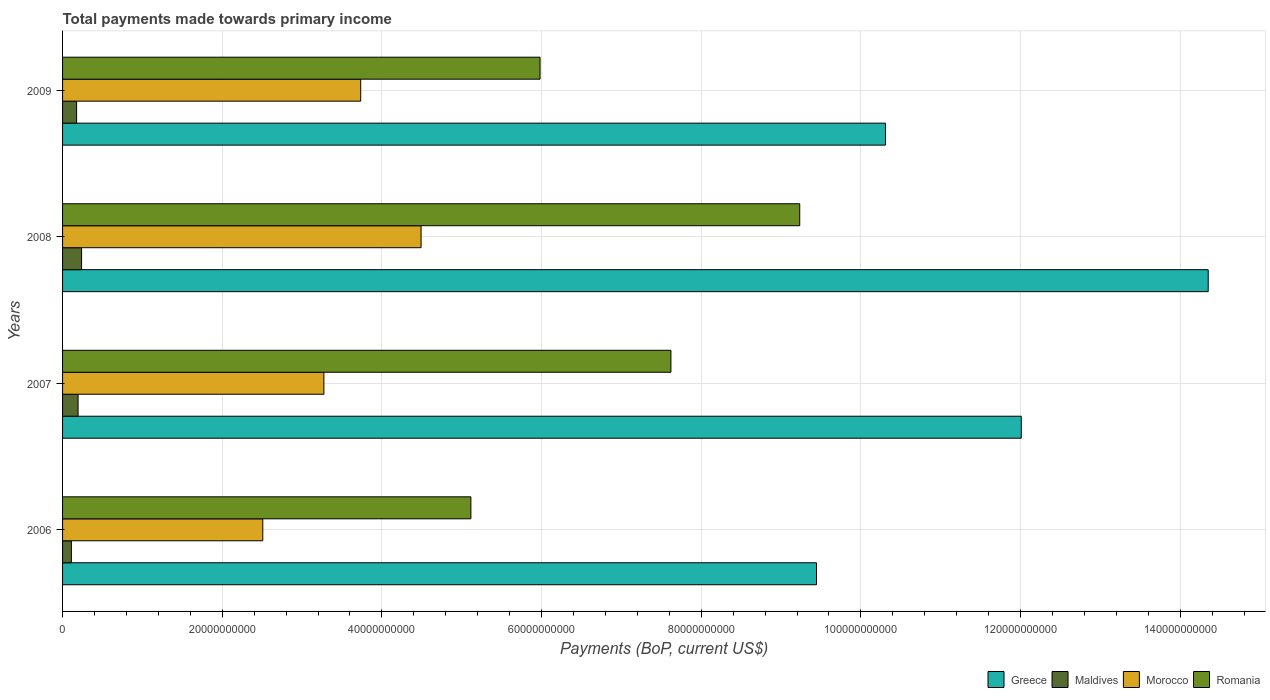How many different coloured bars are there?
Keep it short and to the point. 4. Are the number of bars per tick equal to the number of legend labels?
Your answer should be very brief. Yes. How many bars are there on the 2nd tick from the bottom?
Your answer should be very brief. 4. What is the label of the 2nd group of bars from the top?
Keep it short and to the point. 2008. What is the total payments made towards primary income in Romania in 2009?
Offer a terse response. 5.98e+1. Across all years, what is the maximum total payments made towards primary income in Greece?
Provide a short and direct response. 1.44e+11. Across all years, what is the minimum total payments made towards primary income in Maldives?
Ensure brevity in your answer.  1.10e+09. What is the total total payments made towards primary income in Maldives in the graph?
Your response must be concise. 7.18e+09. What is the difference between the total payments made towards primary income in Maldives in 2006 and that in 2008?
Your answer should be very brief. -1.28e+09. What is the difference between the total payments made towards primary income in Romania in 2006 and the total payments made towards primary income in Morocco in 2009?
Make the answer very short. 1.38e+1. What is the average total payments made towards primary income in Romania per year?
Offer a very short reply. 6.99e+1. In the year 2006, what is the difference between the total payments made towards primary income in Romania and total payments made towards primary income in Maldives?
Offer a very short reply. 5.00e+1. In how many years, is the total payments made towards primary income in Morocco greater than 40000000000 US$?
Make the answer very short. 1. What is the ratio of the total payments made towards primary income in Greece in 2007 to that in 2009?
Your answer should be very brief. 1.17. Is the total payments made towards primary income in Romania in 2008 less than that in 2009?
Offer a terse response. No. What is the difference between the highest and the second highest total payments made towards primary income in Greece?
Provide a short and direct response. 2.34e+1. What is the difference between the highest and the lowest total payments made towards primary income in Greece?
Offer a terse response. 4.91e+1. What does the 1st bar from the top in 2006 represents?
Ensure brevity in your answer.  Romania. What does the 3rd bar from the bottom in 2006 represents?
Your answer should be compact. Morocco. How many bars are there?
Provide a short and direct response. 16. Are all the bars in the graph horizontal?
Provide a short and direct response. Yes. How many years are there in the graph?
Ensure brevity in your answer.  4. What is the difference between two consecutive major ticks on the X-axis?
Ensure brevity in your answer.  2.00e+1. Are the values on the major ticks of X-axis written in scientific E-notation?
Give a very brief answer. No. Does the graph contain any zero values?
Provide a short and direct response. No. Does the graph contain grids?
Your answer should be very brief. Yes. What is the title of the graph?
Your response must be concise. Total payments made towards primary income. Does "Kuwait" appear as one of the legend labels in the graph?
Offer a very short reply. No. What is the label or title of the X-axis?
Offer a terse response. Payments (BoP, current US$). What is the Payments (BoP, current US$) of Greece in 2006?
Provide a short and direct response. 9.44e+1. What is the Payments (BoP, current US$) in Maldives in 2006?
Your response must be concise. 1.10e+09. What is the Payments (BoP, current US$) of Morocco in 2006?
Offer a terse response. 2.51e+1. What is the Payments (BoP, current US$) of Romania in 2006?
Your answer should be compact. 5.11e+1. What is the Payments (BoP, current US$) in Greece in 2007?
Make the answer very short. 1.20e+11. What is the Payments (BoP, current US$) of Maldives in 2007?
Make the answer very short. 1.94e+09. What is the Payments (BoP, current US$) of Morocco in 2007?
Your response must be concise. 3.27e+1. What is the Payments (BoP, current US$) of Romania in 2007?
Offer a very short reply. 7.62e+1. What is the Payments (BoP, current US$) in Greece in 2008?
Provide a succinct answer. 1.44e+11. What is the Payments (BoP, current US$) of Maldives in 2008?
Offer a terse response. 2.38e+09. What is the Payments (BoP, current US$) of Morocco in 2008?
Give a very brief answer. 4.49e+1. What is the Payments (BoP, current US$) of Romania in 2008?
Offer a terse response. 9.23e+1. What is the Payments (BoP, current US$) of Greece in 2009?
Provide a succinct answer. 1.03e+11. What is the Payments (BoP, current US$) of Maldives in 2009?
Ensure brevity in your answer.  1.76e+09. What is the Payments (BoP, current US$) of Morocco in 2009?
Provide a succinct answer. 3.73e+1. What is the Payments (BoP, current US$) in Romania in 2009?
Provide a succinct answer. 5.98e+1. Across all years, what is the maximum Payments (BoP, current US$) of Greece?
Offer a very short reply. 1.44e+11. Across all years, what is the maximum Payments (BoP, current US$) in Maldives?
Make the answer very short. 2.38e+09. Across all years, what is the maximum Payments (BoP, current US$) in Morocco?
Offer a terse response. 4.49e+1. Across all years, what is the maximum Payments (BoP, current US$) of Romania?
Keep it short and to the point. 9.23e+1. Across all years, what is the minimum Payments (BoP, current US$) in Greece?
Ensure brevity in your answer.  9.44e+1. Across all years, what is the minimum Payments (BoP, current US$) of Maldives?
Offer a very short reply. 1.10e+09. Across all years, what is the minimum Payments (BoP, current US$) of Morocco?
Offer a terse response. 2.51e+1. Across all years, what is the minimum Payments (BoP, current US$) in Romania?
Your response must be concise. 5.11e+1. What is the total Payments (BoP, current US$) in Greece in the graph?
Ensure brevity in your answer.  4.61e+11. What is the total Payments (BoP, current US$) of Maldives in the graph?
Keep it short and to the point. 7.18e+09. What is the total Payments (BoP, current US$) in Morocco in the graph?
Offer a very short reply. 1.40e+11. What is the total Payments (BoP, current US$) in Romania in the graph?
Your answer should be very brief. 2.80e+11. What is the difference between the Payments (BoP, current US$) of Greece in 2006 and that in 2007?
Keep it short and to the point. -2.56e+1. What is the difference between the Payments (BoP, current US$) in Maldives in 2006 and that in 2007?
Your answer should be very brief. -8.40e+08. What is the difference between the Payments (BoP, current US$) of Morocco in 2006 and that in 2007?
Your answer should be compact. -7.65e+09. What is the difference between the Payments (BoP, current US$) in Romania in 2006 and that in 2007?
Provide a succinct answer. -2.51e+1. What is the difference between the Payments (BoP, current US$) of Greece in 2006 and that in 2008?
Your response must be concise. -4.91e+1. What is the difference between the Payments (BoP, current US$) of Maldives in 2006 and that in 2008?
Offer a very short reply. -1.28e+09. What is the difference between the Payments (BoP, current US$) of Morocco in 2006 and that in 2008?
Your answer should be very brief. -1.98e+1. What is the difference between the Payments (BoP, current US$) in Romania in 2006 and that in 2008?
Ensure brevity in your answer.  -4.12e+1. What is the difference between the Payments (BoP, current US$) in Greece in 2006 and that in 2009?
Make the answer very short. -8.64e+09. What is the difference between the Payments (BoP, current US$) in Maldives in 2006 and that in 2009?
Ensure brevity in your answer.  -6.55e+08. What is the difference between the Payments (BoP, current US$) in Morocco in 2006 and that in 2009?
Your answer should be compact. -1.23e+1. What is the difference between the Payments (BoP, current US$) of Romania in 2006 and that in 2009?
Keep it short and to the point. -8.66e+09. What is the difference between the Payments (BoP, current US$) of Greece in 2007 and that in 2008?
Offer a terse response. -2.34e+1. What is the difference between the Payments (BoP, current US$) in Maldives in 2007 and that in 2008?
Provide a short and direct response. -4.38e+08. What is the difference between the Payments (BoP, current US$) in Morocco in 2007 and that in 2008?
Your response must be concise. -1.22e+1. What is the difference between the Payments (BoP, current US$) of Romania in 2007 and that in 2008?
Offer a terse response. -1.61e+1. What is the difference between the Payments (BoP, current US$) in Greece in 2007 and that in 2009?
Offer a very short reply. 1.70e+1. What is the difference between the Payments (BoP, current US$) of Maldives in 2007 and that in 2009?
Your response must be concise. 1.85e+08. What is the difference between the Payments (BoP, current US$) of Morocco in 2007 and that in 2009?
Your answer should be compact. -4.61e+09. What is the difference between the Payments (BoP, current US$) in Romania in 2007 and that in 2009?
Give a very brief answer. 1.64e+1. What is the difference between the Payments (BoP, current US$) in Greece in 2008 and that in 2009?
Give a very brief answer. 4.04e+1. What is the difference between the Payments (BoP, current US$) of Maldives in 2008 and that in 2009?
Give a very brief answer. 6.23e+08. What is the difference between the Payments (BoP, current US$) in Morocco in 2008 and that in 2009?
Provide a succinct answer. 7.56e+09. What is the difference between the Payments (BoP, current US$) of Romania in 2008 and that in 2009?
Your answer should be compact. 3.25e+1. What is the difference between the Payments (BoP, current US$) in Greece in 2006 and the Payments (BoP, current US$) in Maldives in 2007?
Your answer should be compact. 9.25e+1. What is the difference between the Payments (BoP, current US$) in Greece in 2006 and the Payments (BoP, current US$) in Morocco in 2007?
Ensure brevity in your answer.  6.17e+1. What is the difference between the Payments (BoP, current US$) in Greece in 2006 and the Payments (BoP, current US$) in Romania in 2007?
Give a very brief answer. 1.82e+1. What is the difference between the Payments (BoP, current US$) of Maldives in 2006 and the Payments (BoP, current US$) of Morocco in 2007?
Ensure brevity in your answer.  -3.16e+1. What is the difference between the Payments (BoP, current US$) in Maldives in 2006 and the Payments (BoP, current US$) in Romania in 2007?
Offer a terse response. -7.51e+1. What is the difference between the Payments (BoP, current US$) of Morocco in 2006 and the Payments (BoP, current US$) of Romania in 2007?
Offer a very short reply. -5.11e+1. What is the difference between the Payments (BoP, current US$) in Greece in 2006 and the Payments (BoP, current US$) in Maldives in 2008?
Provide a short and direct response. 9.21e+1. What is the difference between the Payments (BoP, current US$) in Greece in 2006 and the Payments (BoP, current US$) in Morocco in 2008?
Give a very brief answer. 4.95e+1. What is the difference between the Payments (BoP, current US$) in Greece in 2006 and the Payments (BoP, current US$) in Romania in 2008?
Make the answer very short. 2.10e+09. What is the difference between the Payments (BoP, current US$) in Maldives in 2006 and the Payments (BoP, current US$) in Morocco in 2008?
Offer a very short reply. -4.38e+1. What is the difference between the Payments (BoP, current US$) of Maldives in 2006 and the Payments (BoP, current US$) of Romania in 2008?
Your answer should be very brief. -9.12e+1. What is the difference between the Payments (BoP, current US$) in Morocco in 2006 and the Payments (BoP, current US$) in Romania in 2008?
Offer a terse response. -6.73e+1. What is the difference between the Payments (BoP, current US$) in Greece in 2006 and the Payments (BoP, current US$) in Maldives in 2009?
Give a very brief answer. 9.27e+1. What is the difference between the Payments (BoP, current US$) of Greece in 2006 and the Payments (BoP, current US$) of Morocco in 2009?
Your response must be concise. 5.71e+1. What is the difference between the Payments (BoP, current US$) of Greece in 2006 and the Payments (BoP, current US$) of Romania in 2009?
Provide a succinct answer. 3.46e+1. What is the difference between the Payments (BoP, current US$) of Maldives in 2006 and the Payments (BoP, current US$) of Morocco in 2009?
Offer a very short reply. -3.62e+1. What is the difference between the Payments (BoP, current US$) of Maldives in 2006 and the Payments (BoP, current US$) of Romania in 2009?
Provide a short and direct response. -5.87e+1. What is the difference between the Payments (BoP, current US$) of Morocco in 2006 and the Payments (BoP, current US$) of Romania in 2009?
Ensure brevity in your answer.  -3.47e+1. What is the difference between the Payments (BoP, current US$) in Greece in 2007 and the Payments (BoP, current US$) in Maldives in 2008?
Offer a terse response. 1.18e+11. What is the difference between the Payments (BoP, current US$) in Greece in 2007 and the Payments (BoP, current US$) in Morocco in 2008?
Provide a short and direct response. 7.52e+1. What is the difference between the Payments (BoP, current US$) in Greece in 2007 and the Payments (BoP, current US$) in Romania in 2008?
Your answer should be compact. 2.78e+1. What is the difference between the Payments (BoP, current US$) in Maldives in 2007 and the Payments (BoP, current US$) in Morocco in 2008?
Provide a short and direct response. -4.30e+1. What is the difference between the Payments (BoP, current US$) of Maldives in 2007 and the Payments (BoP, current US$) of Romania in 2008?
Make the answer very short. -9.04e+1. What is the difference between the Payments (BoP, current US$) of Morocco in 2007 and the Payments (BoP, current US$) of Romania in 2008?
Make the answer very short. -5.96e+1. What is the difference between the Payments (BoP, current US$) of Greece in 2007 and the Payments (BoP, current US$) of Maldives in 2009?
Provide a succinct answer. 1.18e+11. What is the difference between the Payments (BoP, current US$) in Greece in 2007 and the Payments (BoP, current US$) in Morocco in 2009?
Your answer should be compact. 8.27e+1. What is the difference between the Payments (BoP, current US$) of Greece in 2007 and the Payments (BoP, current US$) of Romania in 2009?
Keep it short and to the point. 6.03e+1. What is the difference between the Payments (BoP, current US$) of Maldives in 2007 and the Payments (BoP, current US$) of Morocco in 2009?
Your answer should be compact. -3.54e+1. What is the difference between the Payments (BoP, current US$) of Maldives in 2007 and the Payments (BoP, current US$) of Romania in 2009?
Provide a succinct answer. -5.79e+1. What is the difference between the Payments (BoP, current US$) of Morocco in 2007 and the Payments (BoP, current US$) of Romania in 2009?
Your answer should be compact. -2.71e+1. What is the difference between the Payments (BoP, current US$) in Greece in 2008 and the Payments (BoP, current US$) in Maldives in 2009?
Make the answer very short. 1.42e+11. What is the difference between the Payments (BoP, current US$) of Greece in 2008 and the Payments (BoP, current US$) of Morocco in 2009?
Offer a terse response. 1.06e+11. What is the difference between the Payments (BoP, current US$) in Greece in 2008 and the Payments (BoP, current US$) in Romania in 2009?
Offer a terse response. 8.37e+1. What is the difference between the Payments (BoP, current US$) of Maldives in 2008 and the Payments (BoP, current US$) of Morocco in 2009?
Provide a short and direct response. -3.50e+1. What is the difference between the Payments (BoP, current US$) of Maldives in 2008 and the Payments (BoP, current US$) of Romania in 2009?
Provide a succinct answer. -5.74e+1. What is the difference between the Payments (BoP, current US$) in Morocco in 2008 and the Payments (BoP, current US$) in Romania in 2009?
Your answer should be compact. -1.49e+1. What is the average Payments (BoP, current US$) of Greece per year?
Give a very brief answer. 1.15e+11. What is the average Payments (BoP, current US$) in Maldives per year?
Provide a succinct answer. 1.80e+09. What is the average Payments (BoP, current US$) of Morocco per year?
Give a very brief answer. 3.50e+1. What is the average Payments (BoP, current US$) of Romania per year?
Your answer should be compact. 6.99e+1. In the year 2006, what is the difference between the Payments (BoP, current US$) in Greece and Payments (BoP, current US$) in Maldives?
Provide a succinct answer. 9.33e+1. In the year 2006, what is the difference between the Payments (BoP, current US$) in Greece and Payments (BoP, current US$) in Morocco?
Your answer should be very brief. 6.94e+1. In the year 2006, what is the difference between the Payments (BoP, current US$) in Greece and Payments (BoP, current US$) in Romania?
Provide a succinct answer. 4.33e+1. In the year 2006, what is the difference between the Payments (BoP, current US$) in Maldives and Payments (BoP, current US$) in Morocco?
Provide a short and direct response. -2.40e+1. In the year 2006, what is the difference between the Payments (BoP, current US$) in Maldives and Payments (BoP, current US$) in Romania?
Your answer should be compact. -5.00e+1. In the year 2006, what is the difference between the Payments (BoP, current US$) in Morocco and Payments (BoP, current US$) in Romania?
Offer a terse response. -2.61e+1. In the year 2007, what is the difference between the Payments (BoP, current US$) of Greece and Payments (BoP, current US$) of Maldives?
Ensure brevity in your answer.  1.18e+11. In the year 2007, what is the difference between the Payments (BoP, current US$) in Greece and Payments (BoP, current US$) in Morocco?
Your answer should be compact. 8.74e+1. In the year 2007, what is the difference between the Payments (BoP, current US$) in Greece and Payments (BoP, current US$) in Romania?
Make the answer very short. 4.39e+1. In the year 2007, what is the difference between the Payments (BoP, current US$) of Maldives and Payments (BoP, current US$) of Morocco?
Provide a succinct answer. -3.08e+1. In the year 2007, what is the difference between the Payments (BoP, current US$) of Maldives and Payments (BoP, current US$) of Romania?
Give a very brief answer. -7.43e+1. In the year 2007, what is the difference between the Payments (BoP, current US$) of Morocco and Payments (BoP, current US$) of Romania?
Keep it short and to the point. -4.35e+1. In the year 2008, what is the difference between the Payments (BoP, current US$) in Greece and Payments (BoP, current US$) in Maldives?
Your answer should be very brief. 1.41e+11. In the year 2008, what is the difference between the Payments (BoP, current US$) in Greece and Payments (BoP, current US$) in Morocco?
Keep it short and to the point. 9.86e+1. In the year 2008, what is the difference between the Payments (BoP, current US$) of Greece and Payments (BoP, current US$) of Romania?
Offer a terse response. 5.12e+1. In the year 2008, what is the difference between the Payments (BoP, current US$) in Maldives and Payments (BoP, current US$) in Morocco?
Keep it short and to the point. -4.25e+1. In the year 2008, what is the difference between the Payments (BoP, current US$) of Maldives and Payments (BoP, current US$) of Romania?
Your answer should be very brief. -9.00e+1. In the year 2008, what is the difference between the Payments (BoP, current US$) of Morocco and Payments (BoP, current US$) of Romania?
Provide a succinct answer. -4.74e+1. In the year 2009, what is the difference between the Payments (BoP, current US$) in Greece and Payments (BoP, current US$) in Maldives?
Your answer should be compact. 1.01e+11. In the year 2009, what is the difference between the Payments (BoP, current US$) in Greece and Payments (BoP, current US$) in Morocco?
Your answer should be very brief. 6.57e+1. In the year 2009, what is the difference between the Payments (BoP, current US$) in Greece and Payments (BoP, current US$) in Romania?
Keep it short and to the point. 4.33e+1. In the year 2009, what is the difference between the Payments (BoP, current US$) of Maldives and Payments (BoP, current US$) of Morocco?
Give a very brief answer. -3.56e+1. In the year 2009, what is the difference between the Payments (BoP, current US$) of Maldives and Payments (BoP, current US$) of Romania?
Ensure brevity in your answer.  -5.81e+1. In the year 2009, what is the difference between the Payments (BoP, current US$) in Morocco and Payments (BoP, current US$) in Romania?
Your response must be concise. -2.25e+1. What is the ratio of the Payments (BoP, current US$) in Greece in 2006 to that in 2007?
Make the answer very short. 0.79. What is the ratio of the Payments (BoP, current US$) of Maldives in 2006 to that in 2007?
Ensure brevity in your answer.  0.57. What is the ratio of the Payments (BoP, current US$) in Morocco in 2006 to that in 2007?
Provide a succinct answer. 0.77. What is the ratio of the Payments (BoP, current US$) in Romania in 2006 to that in 2007?
Your answer should be compact. 0.67. What is the ratio of the Payments (BoP, current US$) in Greece in 2006 to that in 2008?
Keep it short and to the point. 0.66. What is the ratio of the Payments (BoP, current US$) in Maldives in 2006 to that in 2008?
Keep it short and to the point. 0.46. What is the ratio of the Payments (BoP, current US$) in Morocco in 2006 to that in 2008?
Ensure brevity in your answer.  0.56. What is the ratio of the Payments (BoP, current US$) of Romania in 2006 to that in 2008?
Keep it short and to the point. 0.55. What is the ratio of the Payments (BoP, current US$) of Greece in 2006 to that in 2009?
Give a very brief answer. 0.92. What is the ratio of the Payments (BoP, current US$) of Maldives in 2006 to that in 2009?
Provide a succinct answer. 0.63. What is the ratio of the Payments (BoP, current US$) in Morocco in 2006 to that in 2009?
Keep it short and to the point. 0.67. What is the ratio of the Payments (BoP, current US$) of Romania in 2006 to that in 2009?
Make the answer very short. 0.86. What is the ratio of the Payments (BoP, current US$) in Greece in 2007 to that in 2008?
Your answer should be compact. 0.84. What is the ratio of the Payments (BoP, current US$) of Maldives in 2007 to that in 2008?
Your answer should be very brief. 0.82. What is the ratio of the Payments (BoP, current US$) of Morocco in 2007 to that in 2008?
Ensure brevity in your answer.  0.73. What is the ratio of the Payments (BoP, current US$) in Romania in 2007 to that in 2008?
Ensure brevity in your answer.  0.83. What is the ratio of the Payments (BoP, current US$) in Greece in 2007 to that in 2009?
Make the answer very short. 1.17. What is the ratio of the Payments (BoP, current US$) in Maldives in 2007 to that in 2009?
Give a very brief answer. 1.11. What is the ratio of the Payments (BoP, current US$) of Morocco in 2007 to that in 2009?
Provide a succinct answer. 0.88. What is the ratio of the Payments (BoP, current US$) of Romania in 2007 to that in 2009?
Offer a very short reply. 1.27. What is the ratio of the Payments (BoP, current US$) in Greece in 2008 to that in 2009?
Offer a terse response. 1.39. What is the ratio of the Payments (BoP, current US$) of Maldives in 2008 to that in 2009?
Keep it short and to the point. 1.35. What is the ratio of the Payments (BoP, current US$) in Morocco in 2008 to that in 2009?
Your answer should be very brief. 1.2. What is the ratio of the Payments (BoP, current US$) of Romania in 2008 to that in 2009?
Your answer should be compact. 1.54. What is the difference between the highest and the second highest Payments (BoP, current US$) of Greece?
Provide a succinct answer. 2.34e+1. What is the difference between the highest and the second highest Payments (BoP, current US$) of Maldives?
Provide a short and direct response. 4.38e+08. What is the difference between the highest and the second highest Payments (BoP, current US$) of Morocco?
Make the answer very short. 7.56e+09. What is the difference between the highest and the second highest Payments (BoP, current US$) of Romania?
Give a very brief answer. 1.61e+1. What is the difference between the highest and the lowest Payments (BoP, current US$) in Greece?
Ensure brevity in your answer.  4.91e+1. What is the difference between the highest and the lowest Payments (BoP, current US$) of Maldives?
Your response must be concise. 1.28e+09. What is the difference between the highest and the lowest Payments (BoP, current US$) of Morocco?
Your answer should be compact. 1.98e+1. What is the difference between the highest and the lowest Payments (BoP, current US$) of Romania?
Give a very brief answer. 4.12e+1. 